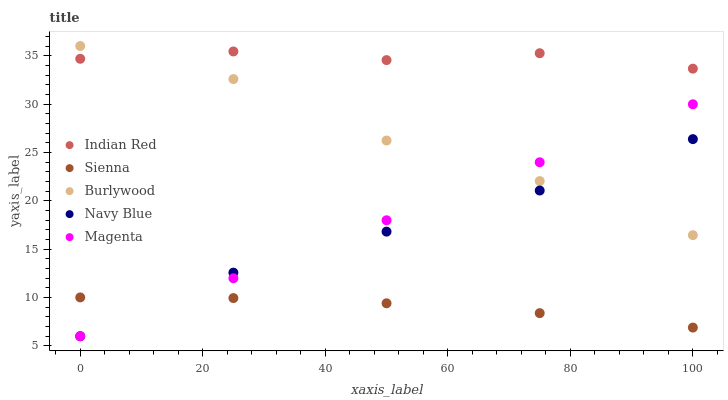Does Sienna have the minimum area under the curve?
Answer yes or no. Yes. Does Indian Red have the maximum area under the curve?
Answer yes or no. Yes. Does Burlywood have the minimum area under the curve?
Answer yes or no. No. Does Burlywood have the maximum area under the curve?
Answer yes or no. No. Is Magenta the smoothest?
Answer yes or no. Yes. Is Burlywood the roughest?
Answer yes or no. Yes. Is Burlywood the smoothest?
Answer yes or no. No. Is Magenta the roughest?
Answer yes or no. No. Does Magenta have the lowest value?
Answer yes or no. Yes. Does Burlywood have the lowest value?
Answer yes or no. No. Does Burlywood have the highest value?
Answer yes or no. Yes. Does Magenta have the highest value?
Answer yes or no. No. Is Magenta less than Indian Red?
Answer yes or no. Yes. Is Indian Red greater than Sienna?
Answer yes or no. Yes. Does Magenta intersect Burlywood?
Answer yes or no. Yes. Is Magenta less than Burlywood?
Answer yes or no. No. Is Magenta greater than Burlywood?
Answer yes or no. No. Does Magenta intersect Indian Red?
Answer yes or no. No. 